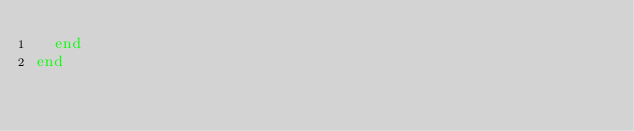<code> <loc_0><loc_0><loc_500><loc_500><_Ruby_>  end
end
</code> 